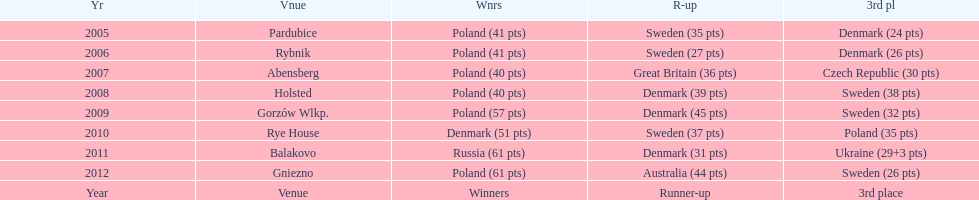What was the last year 3rd place finished with less than 25 points? 2005. Parse the full table. {'header': ['Yr', 'Vnue', 'Wnrs', 'R-up', '3rd pl'], 'rows': [['2005', 'Pardubice', 'Poland (41 pts)', 'Sweden (35 pts)', 'Denmark (24 pts)'], ['2006', 'Rybnik', 'Poland (41 pts)', 'Sweden (27 pts)', 'Denmark (26 pts)'], ['2007', 'Abensberg', 'Poland (40 pts)', 'Great Britain (36 pts)', 'Czech Republic (30 pts)'], ['2008', 'Holsted', 'Poland (40 pts)', 'Denmark (39 pts)', 'Sweden (38 pts)'], ['2009', 'Gorzów Wlkp.', 'Poland (57 pts)', 'Denmark (45 pts)', 'Sweden (32 pts)'], ['2010', 'Rye House', 'Denmark (51 pts)', 'Sweden (37 pts)', 'Poland (35 pts)'], ['2011', 'Balakovo', 'Russia (61 pts)', 'Denmark (31 pts)', 'Ukraine (29+3 pts)'], ['2012', 'Gniezno', 'Poland (61 pts)', 'Australia (44 pts)', 'Sweden (26 pts)'], ['Year', 'Venue', 'Winners', 'Runner-up', '3rd place']]} 